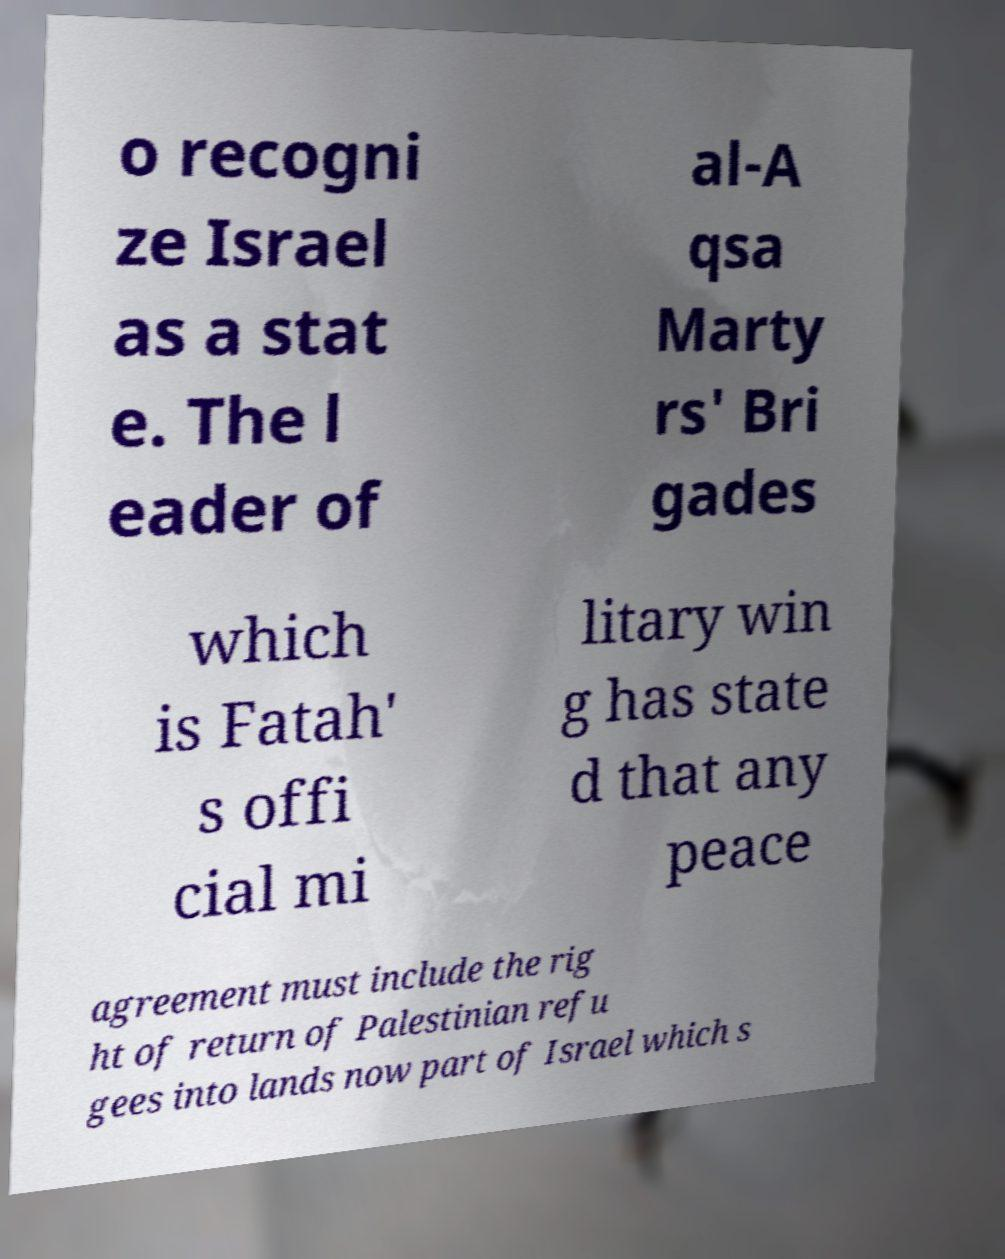Could you extract and type out the text from this image? o recogni ze Israel as a stat e. The l eader of al-A qsa Marty rs' Bri gades which is Fatah' s offi cial mi litary win g has state d that any peace agreement must include the rig ht of return of Palestinian refu gees into lands now part of Israel which s 